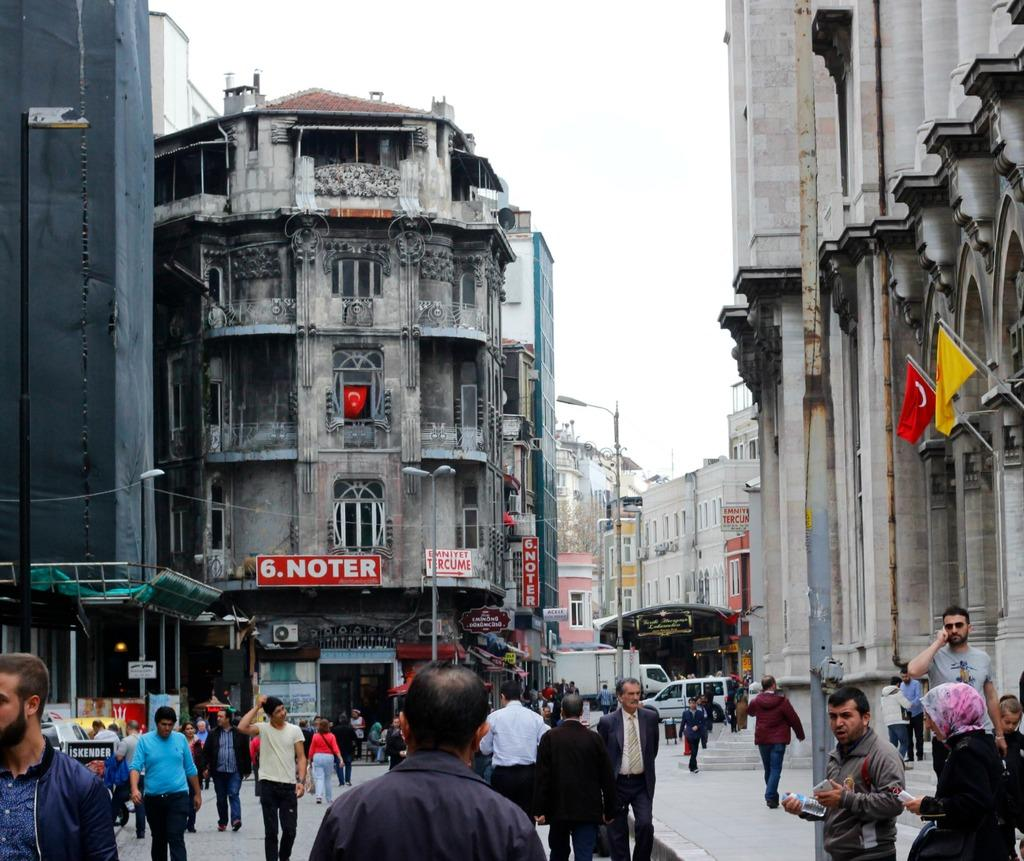What are the people in the image doing? The people in the image are walking on the road. What can be seen in the background of the image? There are buildings visible in the image. What objects are present in the image that might be used for displaying information or advertisements? There are boards present in the image. What additional decorative or symbolic elements can be seen in the image? There are flags in the image. What color is the tongue of the person walking on the road in the image? There is no tongue visible in the image, as it is focused on people walking on the road and other elements in the scene. 